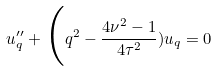<formula> <loc_0><loc_0><loc_500><loc_500>u ^ { \prime \prime } _ { q } + \Big ( q ^ { 2 } - \frac { 4 \nu ^ { 2 } - 1 } { 4 \tau ^ { 2 } } ) u _ { q } = 0</formula> 